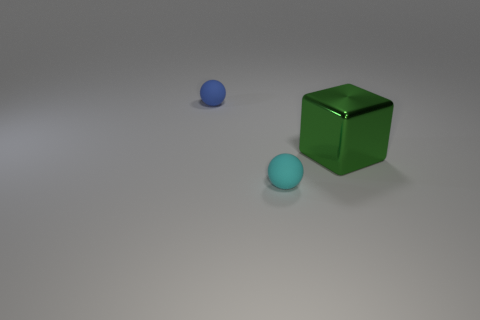There is another object that is the same size as the cyan thing; what shape is it?
Provide a succinct answer. Sphere. Is the material of the tiny thing to the left of the tiny cyan rubber thing the same as the thing in front of the big thing?
Provide a short and direct response. Yes. What is the ball in front of the small matte object to the left of the tiny cyan rubber thing made of?
Ensure brevity in your answer.  Rubber. What is the size of the object to the right of the tiny rubber ball in front of the big green object on the right side of the blue rubber thing?
Give a very brief answer. Large. Is the blue thing the same size as the cyan thing?
Offer a terse response. Yes. There is a rubber object that is in front of the big green metal thing; is its shape the same as the green metallic thing that is in front of the blue ball?
Ensure brevity in your answer.  No. There is a matte sphere in front of the block; is there a big green metallic thing that is on the right side of it?
Keep it short and to the point. Yes. Are there any yellow metal cylinders?
Offer a very short reply. No. What number of green shiny things have the same size as the cyan matte thing?
Provide a short and direct response. 0. What number of objects are right of the tiny cyan rubber thing and left of the green cube?
Provide a short and direct response. 0. 